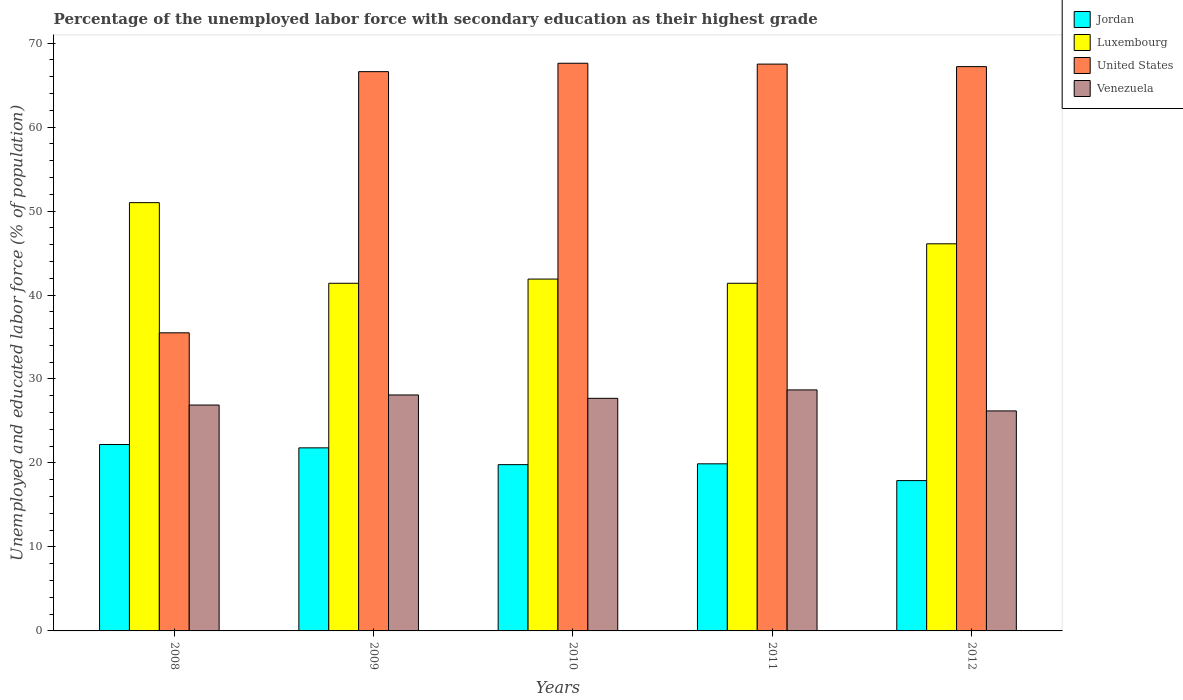How many different coloured bars are there?
Give a very brief answer. 4. How many groups of bars are there?
Your answer should be very brief. 5. Are the number of bars on each tick of the X-axis equal?
Provide a short and direct response. Yes. In how many cases, is the number of bars for a given year not equal to the number of legend labels?
Keep it short and to the point. 0. What is the percentage of the unemployed labor force with secondary education in Venezuela in 2009?
Provide a short and direct response. 28.1. Across all years, what is the maximum percentage of the unemployed labor force with secondary education in Venezuela?
Keep it short and to the point. 28.7. Across all years, what is the minimum percentage of the unemployed labor force with secondary education in United States?
Offer a terse response. 35.5. In which year was the percentage of the unemployed labor force with secondary education in Luxembourg maximum?
Ensure brevity in your answer.  2008. In which year was the percentage of the unemployed labor force with secondary education in Venezuela minimum?
Your answer should be compact. 2012. What is the total percentage of the unemployed labor force with secondary education in Venezuela in the graph?
Provide a short and direct response. 137.6. What is the difference between the percentage of the unemployed labor force with secondary education in United States in 2008 and that in 2009?
Your answer should be very brief. -31.1. What is the difference between the percentage of the unemployed labor force with secondary education in Jordan in 2009 and the percentage of the unemployed labor force with secondary education in United States in 2012?
Give a very brief answer. -45.4. What is the average percentage of the unemployed labor force with secondary education in Venezuela per year?
Your answer should be compact. 27.52. In the year 2011, what is the difference between the percentage of the unemployed labor force with secondary education in Jordan and percentage of the unemployed labor force with secondary education in Luxembourg?
Provide a succinct answer. -21.5. What is the ratio of the percentage of the unemployed labor force with secondary education in United States in 2008 to that in 2012?
Your answer should be very brief. 0.53. What is the difference between the highest and the second highest percentage of the unemployed labor force with secondary education in Venezuela?
Make the answer very short. 0.6. What is the difference between the highest and the lowest percentage of the unemployed labor force with secondary education in United States?
Provide a short and direct response. 32.1. In how many years, is the percentage of the unemployed labor force with secondary education in Venezuela greater than the average percentage of the unemployed labor force with secondary education in Venezuela taken over all years?
Offer a terse response. 3. Is it the case that in every year, the sum of the percentage of the unemployed labor force with secondary education in Venezuela and percentage of the unemployed labor force with secondary education in Luxembourg is greater than the sum of percentage of the unemployed labor force with secondary education in United States and percentage of the unemployed labor force with secondary education in Jordan?
Offer a terse response. No. What does the 4th bar from the left in 2008 represents?
Keep it short and to the point. Venezuela. What does the 4th bar from the right in 2009 represents?
Your answer should be compact. Jordan. How many bars are there?
Keep it short and to the point. 20. How many years are there in the graph?
Provide a succinct answer. 5. Are the values on the major ticks of Y-axis written in scientific E-notation?
Your answer should be very brief. No. Does the graph contain any zero values?
Give a very brief answer. No. Where does the legend appear in the graph?
Provide a succinct answer. Top right. How are the legend labels stacked?
Your answer should be compact. Vertical. What is the title of the graph?
Your answer should be very brief. Percentage of the unemployed labor force with secondary education as their highest grade. Does "Algeria" appear as one of the legend labels in the graph?
Your response must be concise. No. What is the label or title of the Y-axis?
Your answer should be compact. Unemployed and educated labor force (% of population). What is the Unemployed and educated labor force (% of population) of Jordan in 2008?
Your answer should be compact. 22.2. What is the Unemployed and educated labor force (% of population) in Luxembourg in 2008?
Your response must be concise. 51. What is the Unemployed and educated labor force (% of population) of United States in 2008?
Provide a short and direct response. 35.5. What is the Unemployed and educated labor force (% of population) of Venezuela in 2008?
Keep it short and to the point. 26.9. What is the Unemployed and educated labor force (% of population) of Jordan in 2009?
Your answer should be very brief. 21.8. What is the Unemployed and educated labor force (% of population) in Luxembourg in 2009?
Provide a succinct answer. 41.4. What is the Unemployed and educated labor force (% of population) of United States in 2009?
Your response must be concise. 66.6. What is the Unemployed and educated labor force (% of population) of Venezuela in 2009?
Provide a short and direct response. 28.1. What is the Unemployed and educated labor force (% of population) in Jordan in 2010?
Provide a short and direct response. 19.8. What is the Unemployed and educated labor force (% of population) of Luxembourg in 2010?
Your answer should be very brief. 41.9. What is the Unemployed and educated labor force (% of population) in United States in 2010?
Keep it short and to the point. 67.6. What is the Unemployed and educated labor force (% of population) of Venezuela in 2010?
Your response must be concise. 27.7. What is the Unemployed and educated labor force (% of population) of Jordan in 2011?
Offer a terse response. 19.9. What is the Unemployed and educated labor force (% of population) in Luxembourg in 2011?
Provide a short and direct response. 41.4. What is the Unemployed and educated labor force (% of population) in United States in 2011?
Make the answer very short. 67.5. What is the Unemployed and educated labor force (% of population) in Venezuela in 2011?
Your response must be concise. 28.7. What is the Unemployed and educated labor force (% of population) in Jordan in 2012?
Make the answer very short. 17.9. What is the Unemployed and educated labor force (% of population) in Luxembourg in 2012?
Offer a very short reply. 46.1. What is the Unemployed and educated labor force (% of population) of United States in 2012?
Give a very brief answer. 67.2. What is the Unemployed and educated labor force (% of population) of Venezuela in 2012?
Keep it short and to the point. 26.2. Across all years, what is the maximum Unemployed and educated labor force (% of population) of Jordan?
Your answer should be compact. 22.2. Across all years, what is the maximum Unemployed and educated labor force (% of population) of Luxembourg?
Your response must be concise. 51. Across all years, what is the maximum Unemployed and educated labor force (% of population) of United States?
Ensure brevity in your answer.  67.6. Across all years, what is the maximum Unemployed and educated labor force (% of population) in Venezuela?
Keep it short and to the point. 28.7. Across all years, what is the minimum Unemployed and educated labor force (% of population) of Jordan?
Provide a succinct answer. 17.9. Across all years, what is the minimum Unemployed and educated labor force (% of population) in Luxembourg?
Make the answer very short. 41.4. Across all years, what is the minimum Unemployed and educated labor force (% of population) of United States?
Your answer should be very brief. 35.5. Across all years, what is the minimum Unemployed and educated labor force (% of population) of Venezuela?
Your answer should be compact. 26.2. What is the total Unemployed and educated labor force (% of population) of Jordan in the graph?
Provide a short and direct response. 101.6. What is the total Unemployed and educated labor force (% of population) of Luxembourg in the graph?
Ensure brevity in your answer.  221.8. What is the total Unemployed and educated labor force (% of population) in United States in the graph?
Make the answer very short. 304.4. What is the total Unemployed and educated labor force (% of population) of Venezuela in the graph?
Provide a succinct answer. 137.6. What is the difference between the Unemployed and educated labor force (% of population) of Jordan in 2008 and that in 2009?
Your response must be concise. 0.4. What is the difference between the Unemployed and educated labor force (% of population) in United States in 2008 and that in 2009?
Your answer should be compact. -31.1. What is the difference between the Unemployed and educated labor force (% of population) in Luxembourg in 2008 and that in 2010?
Ensure brevity in your answer.  9.1. What is the difference between the Unemployed and educated labor force (% of population) of United States in 2008 and that in 2010?
Provide a succinct answer. -32.1. What is the difference between the Unemployed and educated labor force (% of population) in Jordan in 2008 and that in 2011?
Offer a terse response. 2.3. What is the difference between the Unemployed and educated labor force (% of population) of Luxembourg in 2008 and that in 2011?
Keep it short and to the point. 9.6. What is the difference between the Unemployed and educated labor force (% of population) of United States in 2008 and that in 2011?
Offer a very short reply. -32. What is the difference between the Unemployed and educated labor force (% of population) of Venezuela in 2008 and that in 2011?
Provide a succinct answer. -1.8. What is the difference between the Unemployed and educated labor force (% of population) of Jordan in 2008 and that in 2012?
Your response must be concise. 4.3. What is the difference between the Unemployed and educated labor force (% of population) in Luxembourg in 2008 and that in 2012?
Your answer should be very brief. 4.9. What is the difference between the Unemployed and educated labor force (% of population) in United States in 2008 and that in 2012?
Provide a succinct answer. -31.7. What is the difference between the Unemployed and educated labor force (% of population) of Jordan in 2009 and that in 2010?
Provide a succinct answer. 2. What is the difference between the Unemployed and educated labor force (% of population) of Luxembourg in 2009 and that in 2010?
Your answer should be very brief. -0.5. What is the difference between the Unemployed and educated labor force (% of population) in United States in 2009 and that in 2010?
Make the answer very short. -1. What is the difference between the Unemployed and educated labor force (% of population) of Venezuela in 2009 and that in 2010?
Provide a short and direct response. 0.4. What is the difference between the Unemployed and educated labor force (% of population) in Luxembourg in 2009 and that in 2011?
Offer a terse response. 0. What is the difference between the Unemployed and educated labor force (% of population) in United States in 2009 and that in 2011?
Provide a short and direct response. -0.9. What is the difference between the Unemployed and educated labor force (% of population) of Venezuela in 2009 and that in 2011?
Your response must be concise. -0.6. What is the difference between the Unemployed and educated labor force (% of population) of Jordan in 2009 and that in 2012?
Provide a short and direct response. 3.9. What is the difference between the Unemployed and educated labor force (% of population) of Luxembourg in 2009 and that in 2012?
Your answer should be very brief. -4.7. What is the difference between the Unemployed and educated labor force (% of population) in United States in 2009 and that in 2012?
Make the answer very short. -0.6. What is the difference between the Unemployed and educated labor force (% of population) of United States in 2010 and that in 2011?
Keep it short and to the point. 0.1. What is the difference between the Unemployed and educated labor force (% of population) of Luxembourg in 2010 and that in 2012?
Provide a short and direct response. -4.2. What is the difference between the Unemployed and educated labor force (% of population) in Jordan in 2011 and that in 2012?
Your answer should be compact. 2. What is the difference between the Unemployed and educated labor force (% of population) of Venezuela in 2011 and that in 2012?
Make the answer very short. 2.5. What is the difference between the Unemployed and educated labor force (% of population) of Jordan in 2008 and the Unemployed and educated labor force (% of population) of Luxembourg in 2009?
Provide a short and direct response. -19.2. What is the difference between the Unemployed and educated labor force (% of population) of Jordan in 2008 and the Unemployed and educated labor force (% of population) of United States in 2009?
Offer a terse response. -44.4. What is the difference between the Unemployed and educated labor force (% of population) of Jordan in 2008 and the Unemployed and educated labor force (% of population) of Venezuela in 2009?
Ensure brevity in your answer.  -5.9. What is the difference between the Unemployed and educated labor force (% of population) of Luxembourg in 2008 and the Unemployed and educated labor force (% of population) of United States in 2009?
Ensure brevity in your answer.  -15.6. What is the difference between the Unemployed and educated labor force (% of population) in Luxembourg in 2008 and the Unemployed and educated labor force (% of population) in Venezuela in 2009?
Your answer should be very brief. 22.9. What is the difference between the Unemployed and educated labor force (% of population) in Jordan in 2008 and the Unemployed and educated labor force (% of population) in Luxembourg in 2010?
Your answer should be compact. -19.7. What is the difference between the Unemployed and educated labor force (% of population) in Jordan in 2008 and the Unemployed and educated labor force (% of population) in United States in 2010?
Your answer should be compact. -45.4. What is the difference between the Unemployed and educated labor force (% of population) of Jordan in 2008 and the Unemployed and educated labor force (% of population) of Venezuela in 2010?
Offer a terse response. -5.5. What is the difference between the Unemployed and educated labor force (% of population) in Luxembourg in 2008 and the Unemployed and educated labor force (% of population) in United States in 2010?
Offer a terse response. -16.6. What is the difference between the Unemployed and educated labor force (% of population) in Luxembourg in 2008 and the Unemployed and educated labor force (% of population) in Venezuela in 2010?
Keep it short and to the point. 23.3. What is the difference between the Unemployed and educated labor force (% of population) of Jordan in 2008 and the Unemployed and educated labor force (% of population) of Luxembourg in 2011?
Give a very brief answer. -19.2. What is the difference between the Unemployed and educated labor force (% of population) in Jordan in 2008 and the Unemployed and educated labor force (% of population) in United States in 2011?
Keep it short and to the point. -45.3. What is the difference between the Unemployed and educated labor force (% of population) in Jordan in 2008 and the Unemployed and educated labor force (% of population) in Venezuela in 2011?
Offer a very short reply. -6.5. What is the difference between the Unemployed and educated labor force (% of population) in Luxembourg in 2008 and the Unemployed and educated labor force (% of population) in United States in 2011?
Provide a short and direct response. -16.5. What is the difference between the Unemployed and educated labor force (% of population) in Luxembourg in 2008 and the Unemployed and educated labor force (% of population) in Venezuela in 2011?
Your answer should be compact. 22.3. What is the difference between the Unemployed and educated labor force (% of population) of Jordan in 2008 and the Unemployed and educated labor force (% of population) of Luxembourg in 2012?
Provide a short and direct response. -23.9. What is the difference between the Unemployed and educated labor force (% of population) in Jordan in 2008 and the Unemployed and educated labor force (% of population) in United States in 2012?
Offer a terse response. -45. What is the difference between the Unemployed and educated labor force (% of population) of Jordan in 2008 and the Unemployed and educated labor force (% of population) of Venezuela in 2012?
Your answer should be very brief. -4. What is the difference between the Unemployed and educated labor force (% of population) of Luxembourg in 2008 and the Unemployed and educated labor force (% of population) of United States in 2012?
Keep it short and to the point. -16.2. What is the difference between the Unemployed and educated labor force (% of population) in Luxembourg in 2008 and the Unemployed and educated labor force (% of population) in Venezuela in 2012?
Offer a very short reply. 24.8. What is the difference between the Unemployed and educated labor force (% of population) in United States in 2008 and the Unemployed and educated labor force (% of population) in Venezuela in 2012?
Keep it short and to the point. 9.3. What is the difference between the Unemployed and educated labor force (% of population) of Jordan in 2009 and the Unemployed and educated labor force (% of population) of Luxembourg in 2010?
Offer a terse response. -20.1. What is the difference between the Unemployed and educated labor force (% of population) in Jordan in 2009 and the Unemployed and educated labor force (% of population) in United States in 2010?
Your response must be concise. -45.8. What is the difference between the Unemployed and educated labor force (% of population) in Jordan in 2009 and the Unemployed and educated labor force (% of population) in Venezuela in 2010?
Your answer should be very brief. -5.9. What is the difference between the Unemployed and educated labor force (% of population) of Luxembourg in 2009 and the Unemployed and educated labor force (% of population) of United States in 2010?
Provide a short and direct response. -26.2. What is the difference between the Unemployed and educated labor force (% of population) in Luxembourg in 2009 and the Unemployed and educated labor force (% of population) in Venezuela in 2010?
Provide a short and direct response. 13.7. What is the difference between the Unemployed and educated labor force (% of population) in United States in 2009 and the Unemployed and educated labor force (% of population) in Venezuela in 2010?
Ensure brevity in your answer.  38.9. What is the difference between the Unemployed and educated labor force (% of population) in Jordan in 2009 and the Unemployed and educated labor force (% of population) in Luxembourg in 2011?
Your answer should be compact. -19.6. What is the difference between the Unemployed and educated labor force (% of population) in Jordan in 2009 and the Unemployed and educated labor force (% of population) in United States in 2011?
Your answer should be compact. -45.7. What is the difference between the Unemployed and educated labor force (% of population) in Luxembourg in 2009 and the Unemployed and educated labor force (% of population) in United States in 2011?
Your answer should be very brief. -26.1. What is the difference between the Unemployed and educated labor force (% of population) of Luxembourg in 2009 and the Unemployed and educated labor force (% of population) of Venezuela in 2011?
Make the answer very short. 12.7. What is the difference between the Unemployed and educated labor force (% of population) of United States in 2009 and the Unemployed and educated labor force (% of population) of Venezuela in 2011?
Offer a very short reply. 37.9. What is the difference between the Unemployed and educated labor force (% of population) in Jordan in 2009 and the Unemployed and educated labor force (% of population) in Luxembourg in 2012?
Your answer should be very brief. -24.3. What is the difference between the Unemployed and educated labor force (% of population) in Jordan in 2009 and the Unemployed and educated labor force (% of population) in United States in 2012?
Offer a terse response. -45.4. What is the difference between the Unemployed and educated labor force (% of population) in Luxembourg in 2009 and the Unemployed and educated labor force (% of population) in United States in 2012?
Offer a terse response. -25.8. What is the difference between the Unemployed and educated labor force (% of population) in Luxembourg in 2009 and the Unemployed and educated labor force (% of population) in Venezuela in 2012?
Make the answer very short. 15.2. What is the difference between the Unemployed and educated labor force (% of population) in United States in 2009 and the Unemployed and educated labor force (% of population) in Venezuela in 2012?
Ensure brevity in your answer.  40.4. What is the difference between the Unemployed and educated labor force (% of population) in Jordan in 2010 and the Unemployed and educated labor force (% of population) in Luxembourg in 2011?
Provide a short and direct response. -21.6. What is the difference between the Unemployed and educated labor force (% of population) of Jordan in 2010 and the Unemployed and educated labor force (% of population) of United States in 2011?
Your answer should be very brief. -47.7. What is the difference between the Unemployed and educated labor force (% of population) of Jordan in 2010 and the Unemployed and educated labor force (% of population) of Venezuela in 2011?
Provide a short and direct response. -8.9. What is the difference between the Unemployed and educated labor force (% of population) in Luxembourg in 2010 and the Unemployed and educated labor force (% of population) in United States in 2011?
Provide a succinct answer. -25.6. What is the difference between the Unemployed and educated labor force (% of population) of Luxembourg in 2010 and the Unemployed and educated labor force (% of population) of Venezuela in 2011?
Provide a short and direct response. 13.2. What is the difference between the Unemployed and educated labor force (% of population) of United States in 2010 and the Unemployed and educated labor force (% of population) of Venezuela in 2011?
Keep it short and to the point. 38.9. What is the difference between the Unemployed and educated labor force (% of population) in Jordan in 2010 and the Unemployed and educated labor force (% of population) in Luxembourg in 2012?
Give a very brief answer. -26.3. What is the difference between the Unemployed and educated labor force (% of population) of Jordan in 2010 and the Unemployed and educated labor force (% of population) of United States in 2012?
Give a very brief answer. -47.4. What is the difference between the Unemployed and educated labor force (% of population) of Luxembourg in 2010 and the Unemployed and educated labor force (% of population) of United States in 2012?
Ensure brevity in your answer.  -25.3. What is the difference between the Unemployed and educated labor force (% of population) in United States in 2010 and the Unemployed and educated labor force (% of population) in Venezuela in 2012?
Offer a terse response. 41.4. What is the difference between the Unemployed and educated labor force (% of population) of Jordan in 2011 and the Unemployed and educated labor force (% of population) of Luxembourg in 2012?
Provide a short and direct response. -26.2. What is the difference between the Unemployed and educated labor force (% of population) in Jordan in 2011 and the Unemployed and educated labor force (% of population) in United States in 2012?
Offer a very short reply. -47.3. What is the difference between the Unemployed and educated labor force (% of population) of Luxembourg in 2011 and the Unemployed and educated labor force (% of population) of United States in 2012?
Your answer should be compact. -25.8. What is the difference between the Unemployed and educated labor force (% of population) in Luxembourg in 2011 and the Unemployed and educated labor force (% of population) in Venezuela in 2012?
Provide a short and direct response. 15.2. What is the difference between the Unemployed and educated labor force (% of population) in United States in 2011 and the Unemployed and educated labor force (% of population) in Venezuela in 2012?
Keep it short and to the point. 41.3. What is the average Unemployed and educated labor force (% of population) of Jordan per year?
Ensure brevity in your answer.  20.32. What is the average Unemployed and educated labor force (% of population) of Luxembourg per year?
Your response must be concise. 44.36. What is the average Unemployed and educated labor force (% of population) of United States per year?
Make the answer very short. 60.88. What is the average Unemployed and educated labor force (% of population) in Venezuela per year?
Your response must be concise. 27.52. In the year 2008, what is the difference between the Unemployed and educated labor force (% of population) in Jordan and Unemployed and educated labor force (% of population) in Luxembourg?
Your answer should be very brief. -28.8. In the year 2008, what is the difference between the Unemployed and educated labor force (% of population) in Jordan and Unemployed and educated labor force (% of population) in United States?
Make the answer very short. -13.3. In the year 2008, what is the difference between the Unemployed and educated labor force (% of population) of Jordan and Unemployed and educated labor force (% of population) of Venezuela?
Your answer should be compact. -4.7. In the year 2008, what is the difference between the Unemployed and educated labor force (% of population) of Luxembourg and Unemployed and educated labor force (% of population) of Venezuela?
Your answer should be very brief. 24.1. In the year 2008, what is the difference between the Unemployed and educated labor force (% of population) in United States and Unemployed and educated labor force (% of population) in Venezuela?
Offer a terse response. 8.6. In the year 2009, what is the difference between the Unemployed and educated labor force (% of population) in Jordan and Unemployed and educated labor force (% of population) in Luxembourg?
Provide a short and direct response. -19.6. In the year 2009, what is the difference between the Unemployed and educated labor force (% of population) in Jordan and Unemployed and educated labor force (% of population) in United States?
Your answer should be compact. -44.8. In the year 2009, what is the difference between the Unemployed and educated labor force (% of population) in Luxembourg and Unemployed and educated labor force (% of population) in United States?
Offer a very short reply. -25.2. In the year 2009, what is the difference between the Unemployed and educated labor force (% of population) in Luxembourg and Unemployed and educated labor force (% of population) in Venezuela?
Offer a terse response. 13.3. In the year 2009, what is the difference between the Unemployed and educated labor force (% of population) in United States and Unemployed and educated labor force (% of population) in Venezuela?
Your answer should be compact. 38.5. In the year 2010, what is the difference between the Unemployed and educated labor force (% of population) of Jordan and Unemployed and educated labor force (% of population) of Luxembourg?
Your answer should be compact. -22.1. In the year 2010, what is the difference between the Unemployed and educated labor force (% of population) of Jordan and Unemployed and educated labor force (% of population) of United States?
Ensure brevity in your answer.  -47.8. In the year 2010, what is the difference between the Unemployed and educated labor force (% of population) in Jordan and Unemployed and educated labor force (% of population) in Venezuela?
Keep it short and to the point. -7.9. In the year 2010, what is the difference between the Unemployed and educated labor force (% of population) of Luxembourg and Unemployed and educated labor force (% of population) of United States?
Ensure brevity in your answer.  -25.7. In the year 2010, what is the difference between the Unemployed and educated labor force (% of population) in Luxembourg and Unemployed and educated labor force (% of population) in Venezuela?
Your answer should be compact. 14.2. In the year 2010, what is the difference between the Unemployed and educated labor force (% of population) of United States and Unemployed and educated labor force (% of population) of Venezuela?
Ensure brevity in your answer.  39.9. In the year 2011, what is the difference between the Unemployed and educated labor force (% of population) in Jordan and Unemployed and educated labor force (% of population) in Luxembourg?
Provide a succinct answer. -21.5. In the year 2011, what is the difference between the Unemployed and educated labor force (% of population) of Jordan and Unemployed and educated labor force (% of population) of United States?
Ensure brevity in your answer.  -47.6. In the year 2011, what is the difference between the Unemployed and educated labor force (% of population) of Jordan and Unemployed and educated labor force (% of population) of Venezuela?
Your response must be concise. -8.8. In the year 2011, what is the difference between the Unemployed and educated labor force (% of population) in Luxembourg and Unemployed and educated labor force (% of population) in United States?
Provide a short and direct response. -26.1. In the year 2011, what is the difference between the Unemployed and educated labor force (% of population) in Luxembourg and Unemployed and educated labor force (% of population) in Venezuela?
Ensure brevity in your answer.  12.7. In the year 2011, what is the difference between the Unemployed and educated labor force (% of population) in United States and Unemployed and educated labor force (% of population) in Venezuela?
Offer a terse response. 38.8. In the year 2012, what is the difference between the Unemployed and educated labor force (% of population) in Jordan and Unemployed and educated labor force (% of population) in Luxembourg?
Keep it short and to the point. -28.2. In the year 2012, what is the difference between the Unemployed and educated labor force (% of population) of Jordan and Unemployed and educated labor force (% of population) of United States?
Offer a terse response. -49.3. In the year 2012, what is the difference between the Unemployed and educated labor force (% of population) of Luxembourg and Unemployed and educated labor force (% of population) of United States?
Provide a short and direct response. -21.1. In the year 2012, what is the difference between the Unemployed and educated labor force (% of population) of Luxembourg and Unemployed and educated labor force (% of population) of Venezuela?
Offer a terse response. 19.9. What is the ratio of the Unemployed and educated labor force (% of population) of Jordan in 2008 to that in 2009?
Keep it short and to the point. 1.02. What is the ratio of the Unemployed and educated labor force (% of population) in Luxembourg in 2008 to that in 2009?
Ensure brevity in your answer.  1.23. What is the ratio of the Unemployed and educated labor force (% of population) of United States in 2008 to that in 2009?
Provide a short and direct response. 0.53. What is the ratio of the Unemployed and educated labor force (% of population) in Venezuela in 2008 to that in 2009?
Keep it short and to the point. 0.96. What is the ratio of the Unemployed and educated labor force (% of population) in Jordan in 2008 to that in 2010?
Keep it short and to the point. 1.12. What is the ratio of the Unemployed and educated labor force (% of population) in Luxembourg in 2008 to that in 2010?
Give a very brief answer. 1.22. What is the ratio of the Unemployed and educated labor force (% of population) of United States in 2008 to that in 2010?
Offer a very short reply. 0.53. What is the ratio of the Unemployed and educated labor force (% of population) of Venezuela in 2008 to that in 2010?
Keep it short and to the point. 0.97. What is the ratio of the Unemployed and educated labor force (% of population) in Jordan in 2008 to that in 2011?
Offer a terse response. 1.12. What is the ratio of the Unemployed and educated labor force (% of population) in Luxembourg in 2008 to that in 2011?
Your answer should be compact. 1.23. What is the ratio of the Unemployed and educated labor force (% of population) of United States in 2008 to that in 2011?
Give a very brief answer. 0.53. What is the ratio of the Unemployed and educated labor force (% of population) in Venezuela in 2008 to that in 2011?
Give a very brief answer. 0.94. What is the ratio of the Unemployed and educated labor force (% of population) of Jordan in 2008 to that in 2012?
Ensure brevity in your answer.  1.24. What is the ratio of the Unemployed and educated labor force (% of population) of Luxembourg in 2008 to that in 2012?
Provide a succinct answer. 1.11. What is the ratio of the Unemployed and educated labor force (% of population) of United States in 2008 to that in 2012?
Your answer should be compact. 0.53. What is the ratio of the Unemployed and educated labor force (% of population) in Venezuela in 2008 to that in 2012?
Your answer should be compact. 1.03. What is the ratio of the Unemployed and educated labor force (% of population) in Jordan in 2009 to that in 2010?
Your response must be concise. 1.1. What is the ratio of the Unemployed and educated labor force (% of population) in Luxembourg in 2009 to that in 2010?
Your response must be concise. 0.99. What is the ratio of the Unemployed and educated labor force (% of population) of United States in 2009 to that in 2010?
Ensure brevity in your answer.  0.99. What is the ratio of the Unemployed and educated labor force (% of population) in Venezuela in 2009 to that in 2010?
Your response must be concise. 1.01. What is the ratio of the Unemployed and educated labor force (% of population) of Jordan in 2009 to that in 2011?
Offer a very short reply. 1.1. What is the ratio of the Unemployed and educated labor force (% of population) in Luxembourg in 2009 to that in 2011?
Ensure brevity in your answer.  1. What is the ratio of the Unemployed and educated labor force (% of population) of United States in 2009 to that in 2011?
Provide a succinct answer. 0.99. What is the ratio of the Unemployed and educated labor force (% of population) in Venezuela in 2009 to that in 2011?
Ensure brevity in your answer.  0.98. What is the ratio of the Unemployed and educated labor force (% of population) of Jordan in 2009 to that in 2012?
Keep it short and to the point. 1.22. What is the ratio of the Unemployed and educated labor force (% of population) of Luxembourg in 2009 to that in 2012?
Give a very brief answer. 0.9. What is the ratio of the Unemployed and educated labor force (% of population) in Venezuela in 2009 to that in 2012?
Ensure brevity in your answer.  1.07. What is the ratio of the Unemployed and educated labor force (% of population) of Jordan in 2010 to that in 2011?
Offer a terse response. 0.99. What is the ratio of the Unemployed and educated labor force (% of population) of Luxembourg in 2010 to that in 2011?
Your answer should be compact. 1.01. What is the ratio of the Unemployed and educated labor force (% of population) of Venezuela in 2010 to that in 2011?
Offer a terse response. 0.97. What is the ratio of the Unemployed and educated labor force (% of population) of Jordan in 2010 to that in 2012?
Provide a succinct answer. 1.11. What is the ratio of the Unemployed and educated labor force (% of population) in Luxembourg in 2010 to that in 2012?
Ensure brevity in your answer.  0.91. What is the ratio of the Unemployed and educated labor force (% of population) in Venezuela in 2010 to that in 2012?
Your response must be concise. 1.06. What is the ratio of the Unemployed and educated labor force (% of population) of Jordan in 2011 to that in 2012?
Offer a terse response. 1.11. What is the ratio of the Unemployed and educated labor force (% of population) of Luxembourg in 2011 to that in 2012?
Offer a terse response. 0.9. What is the ratio of the Unemployed and educated labor force (% of population) of United States in 2011 to that in 2012?
Your response must be concise. 1. What is the ratio of the Unemployed and educated labor force (% of population) in Venezuela in 2011 to that in 2012?
Your answer should be compact. 1.1. What is the difference between the highest and the second highest Unemployed and educated labor force (% of population) of Jordan?
Offer a terse response. 0.4. What is the difference between the highest and the second highest Unemployed and educated labor force (% of population) in United States?
Offer a very short reply. 0.1. What is the difference between the highest and the second highest Unemployed and educated labor force (% of population) of Venezuela?
Give a very brief answer. 0.6. What is the difference between the highest and the lowest Unemployed and educated labor force (% of population) in United States?
Your answer should be compact. 32.1. 